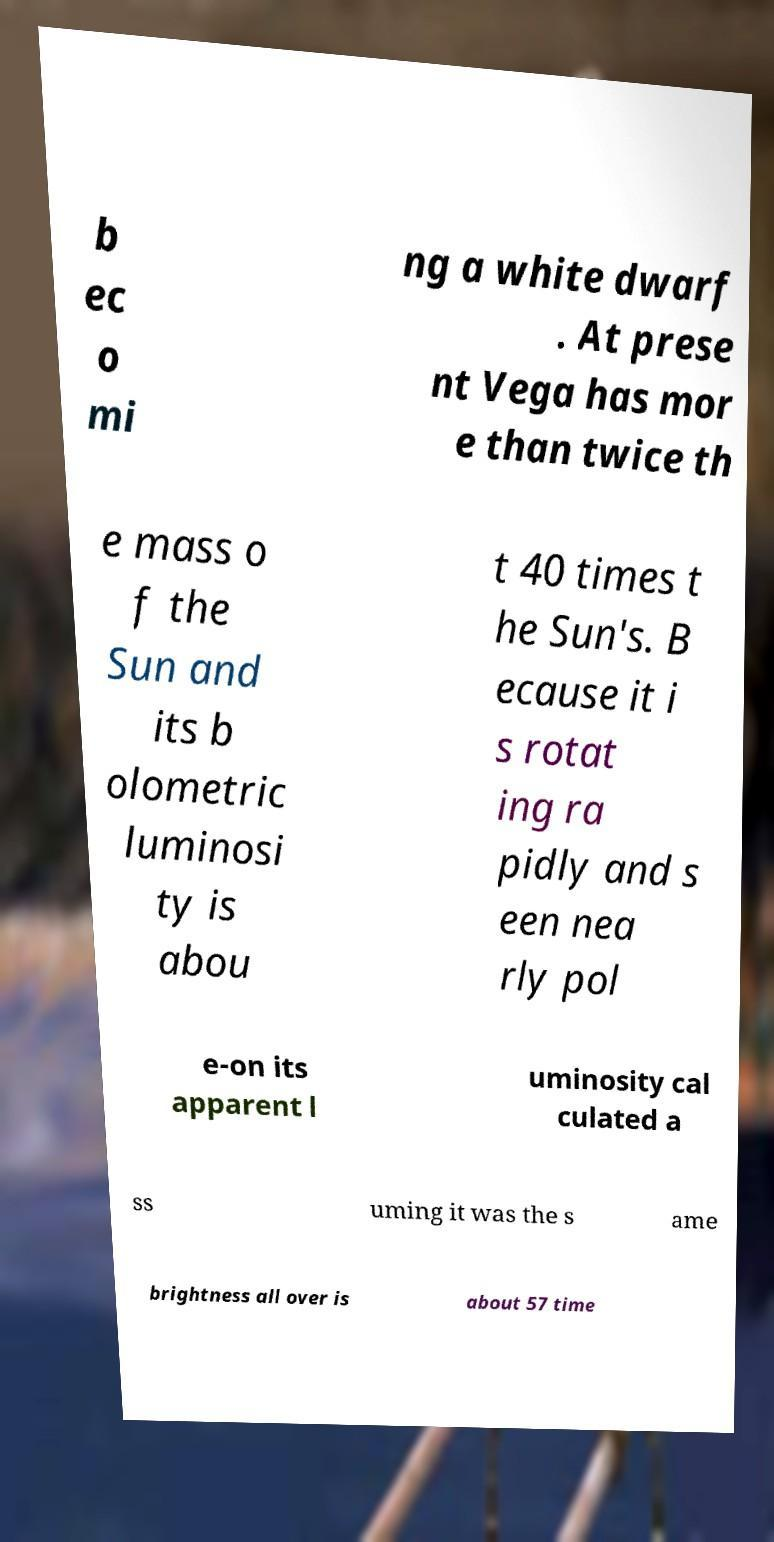What messages or text are displayed in this image? I need them in a readable, typed format. b ec o mi ng a white dwarf . At prese nt Vega has mor e than twice th e mass o f the Sun and its b olometric luminosi ty is abou t 40 times t he Sun's. B ecause it i s rotat ing ra pidly and s een nea rly pol e-on its apparent l uminosity cal culated a ss uming it was the s ame brightness all over is about 57 time 